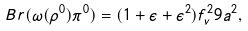Convert formula to latex. <formula><loc_0><loc_0><loc_500><loc_500>B r ( \omega ( \rho ^ { 0 } ) \pi ^ { 0 } ) = ( 1 + \epsilon + \epsilon ^ { 2 } ) f ^ { 2 } _ { v } 9 a ^ { 2 } ,</formula> 